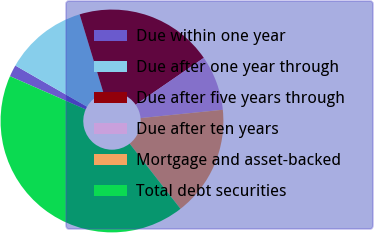Convert chart. <chart><loc_0><loc_0><loc_500><loc_500><pie_chart><fcel>Due within one year<fcel>Due after one year through<fcel>Due after five years through<fcel>Due after ten years<fcel>Mortgage and asset-backed<fcel>Total debt securities<nl><fcel>1.71%<fcel>12.02%<fcel>20.1%<fcel>7.98%<fcel>16.06%<fcel>42.11%<nl></chart> 